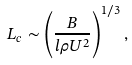<formula> <loc_0><loc_0><loc_500><loc_500>L _ { c } \sim \left ( \frac { B } { l \rho U ^ { 2 } } \right ) ^ { 1 / 3 } ,</formula> 